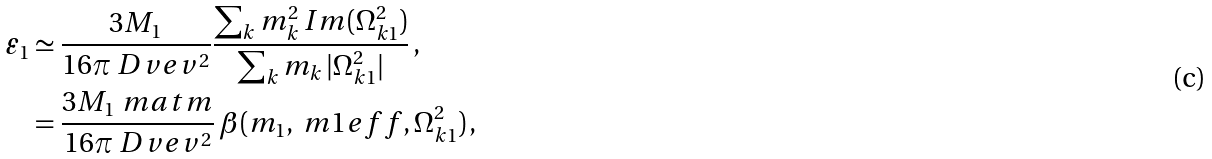Convert formula to latex. <formula><loc_0><loc_0><loc_500><loc_500>\varepsilon _ { 1 } & \simeq \frac { 3 M _ { 1 } } { 1 6 \pi \ D v e v ^ { 2 } } \frac { \sum _ { k } m _ { k } ^ { 2 } \, I m ( \Omega _ { k 1 } ^ { 2 } ) } { \sum _ { k } m _ { k } \, | \Omega _ { k 1 } ^ { 2 } | } \, , \\ & = \frac { 3 M _ { 1 } \ m a t m } { 1 6 \pi \ D v e v ^ { 2 } } \, \beta ( m _ { 1 } , \ m 1 e f f , \Omega _ { k 1 } ^ { 2 } ) \, ,</formula> 